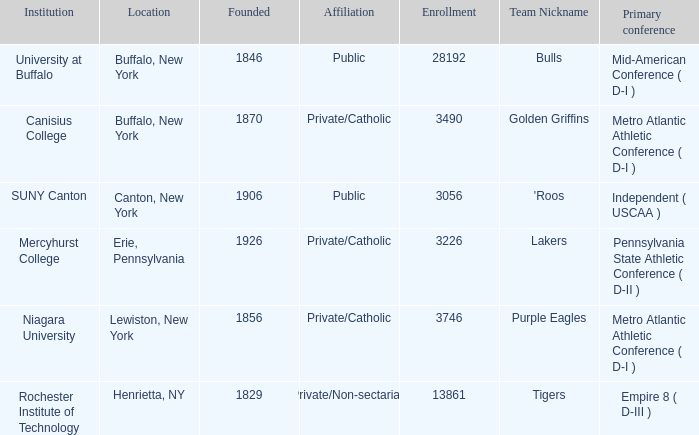Can you parse all the data within this table? {'header': ['Institution', 'Location', 'Founded', 'Affiliation', 'Enrollment', 'Team Nickname', 'Primary conference'], 'rows': [['University at Buffalo', 'Buffalo, New York', '1846', 'Public', '28192', 'Bulls', 'Mid-American Conference ( D-I )'], ['Canisius College', 'Buffalo, New York', '1870', 'Private/Catholic', '3490', 'Golden Griffins', 'Metro Atlantic Athletic Conference ( D-I )'], ['SUNY Canton', 'Canton, New York', '1906', 'Public', '3056', "'Roos", 'Independent ( USCAA )'], ['Mercyhurst College', 'Erie, Pennsylvania', '1926', 'Private/Catholic', '3226', 'Lakers', 'Pennsylvania State Athletic Conference ( D-II )'], ['Niagara University', 'Lewiston, New York', '1856', 'Private/Catholic', '3746', 'Purple Eagles', 'Metro Atlantic Athletic Conference ( D-I )'], ['Rochester Institute of Technology', 'Henrietta, NY', '1829', 'Private/Non-sectarian', '13861', 'Tigers', 'Empire 8 ( D-III )']]} What alliance is erie, pennsylvania part of? Private/Catholic. 